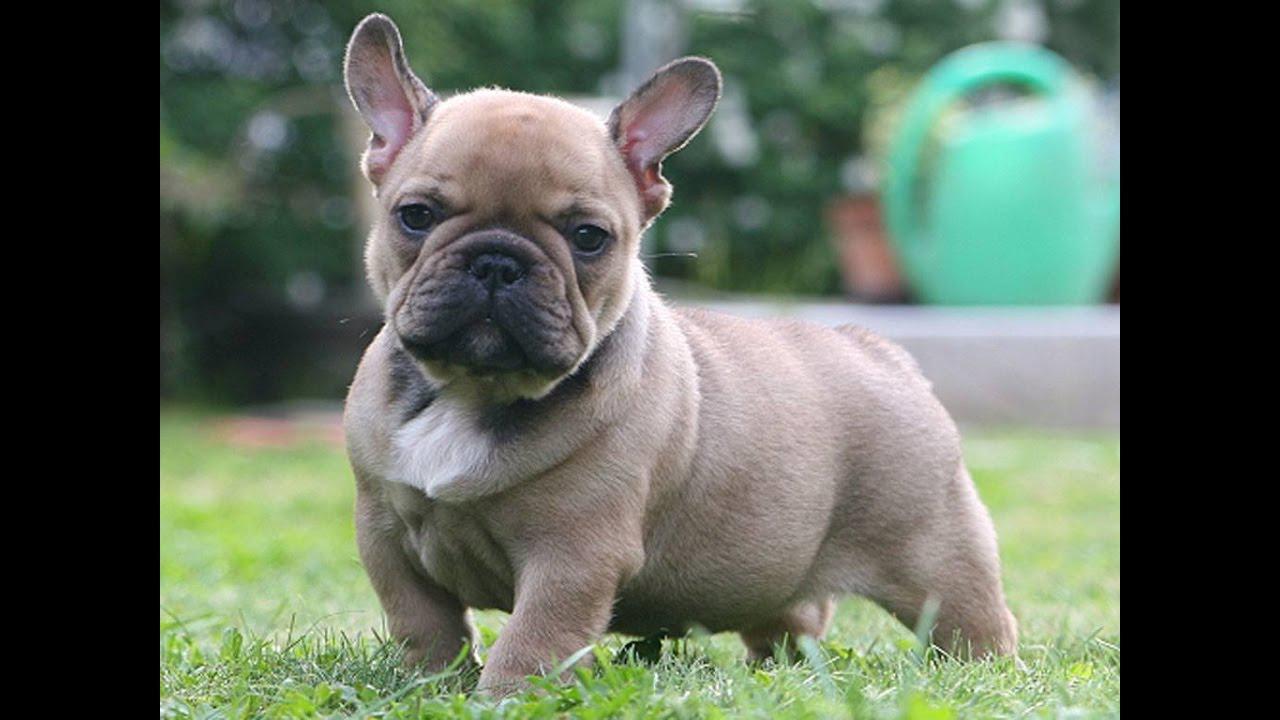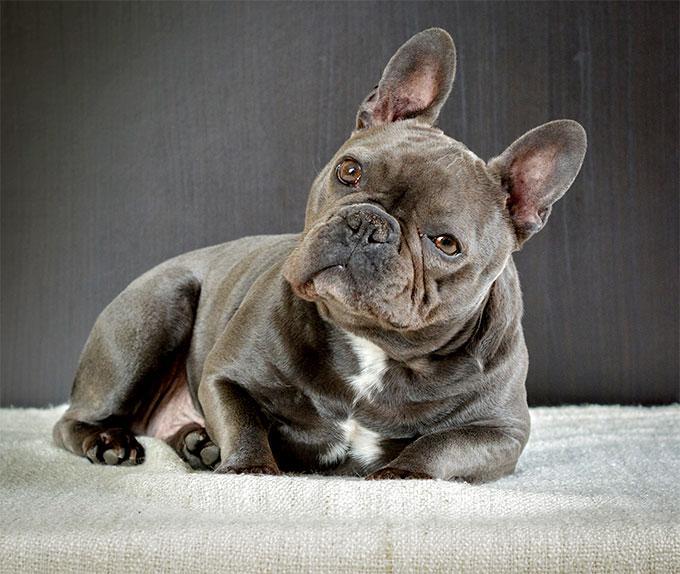The first image is the image on the left, the second image is the image on the right. Analyze the images presented: Is the assertion "There is one dog lying on its stomach in the image on the right." valid? Answer yes or no. Yes. 